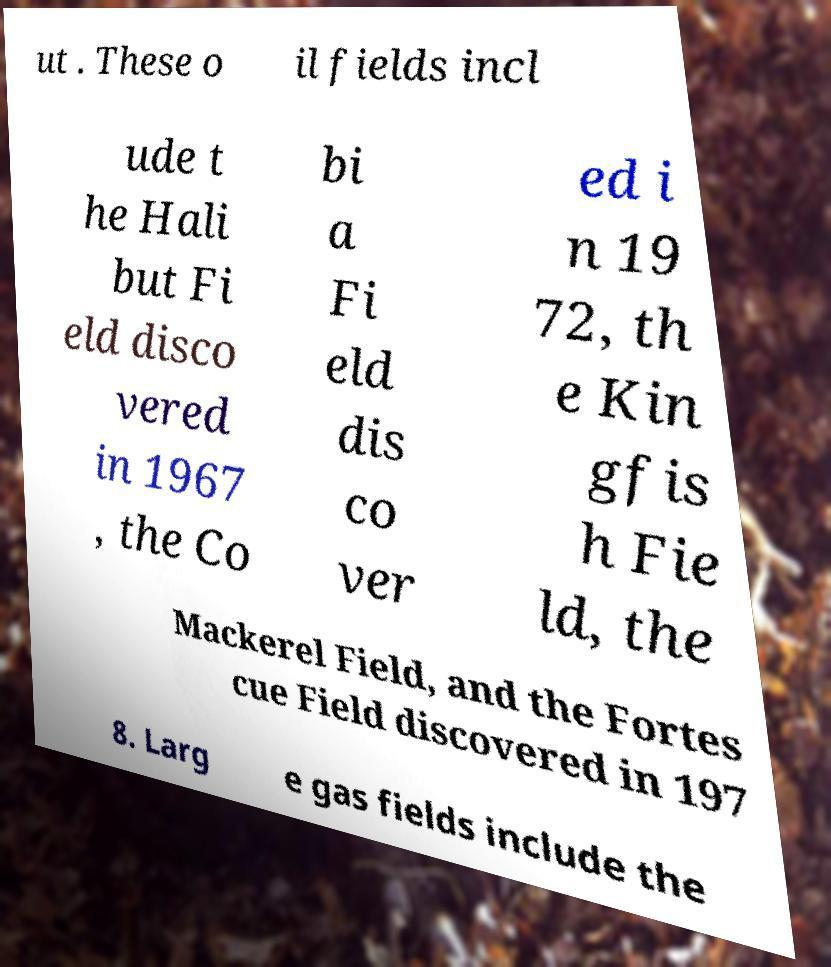Please identify and transcribe the text found in this image. ut . These o il fields incl ude t he Hali but Fi eld disco vered in 1967 , the Co bi a Fi eld dis co ver ed i n 19 72, th e Kin gfis h Fie ld, the Mackerel Field, and the Fortes cue Field discovered in 197 8. Larg e gas fields include the 